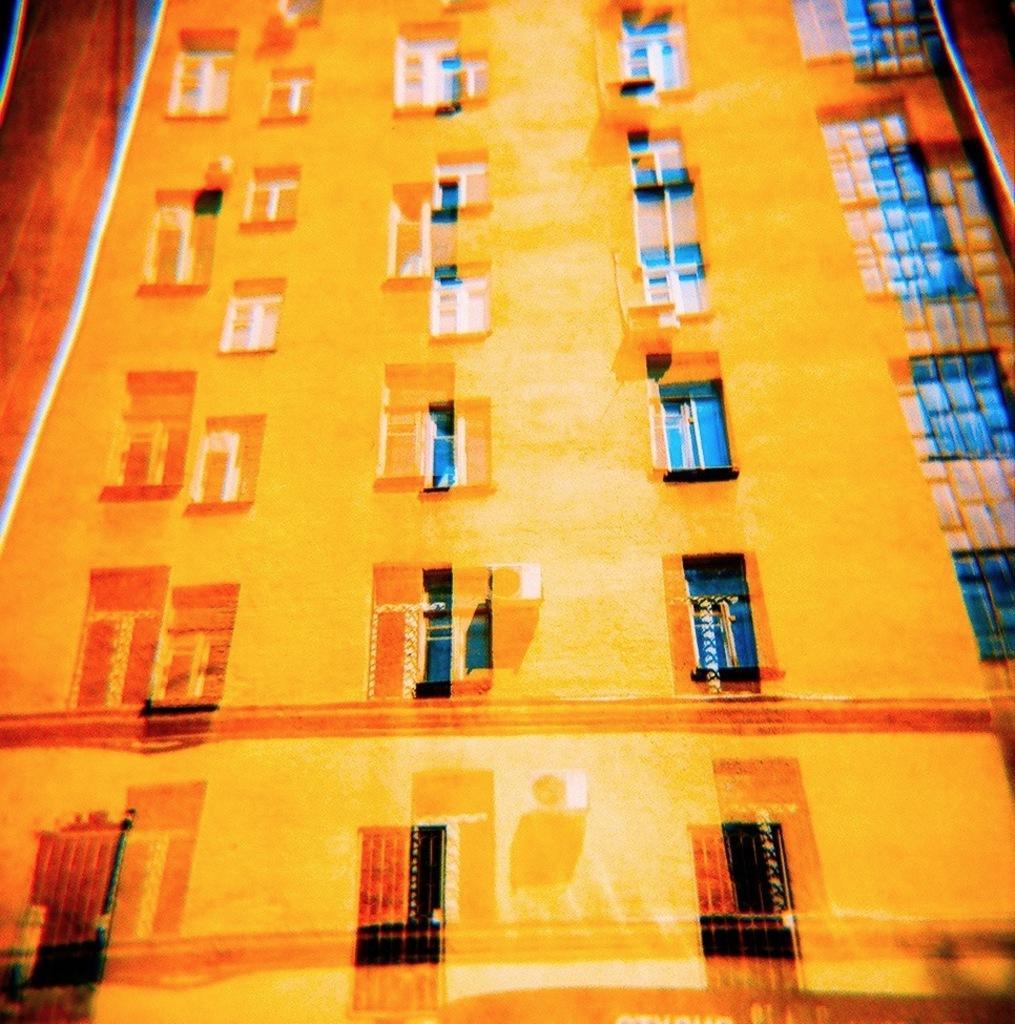Describe this image in one or two sentences. This picture is an edited picture. In this image there is a building. There are curtains behind the window. 